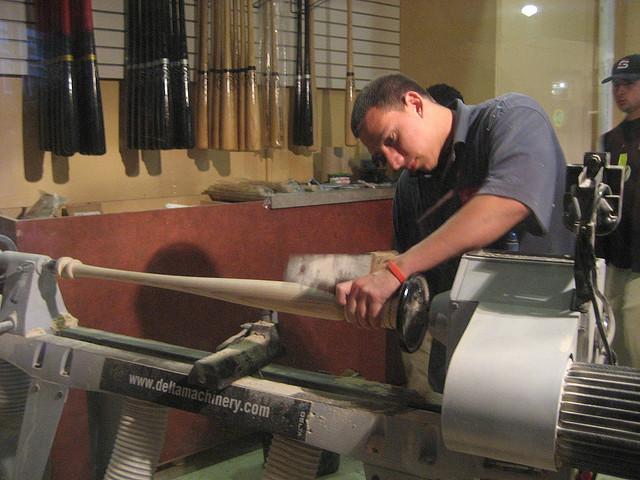What is the man shaping?
Write a very short answer. Baseball bat. What material is the man working with?
Keep it brief. Wood. What does the man have on his wrist?
Give a very brief answer. Wristband. 